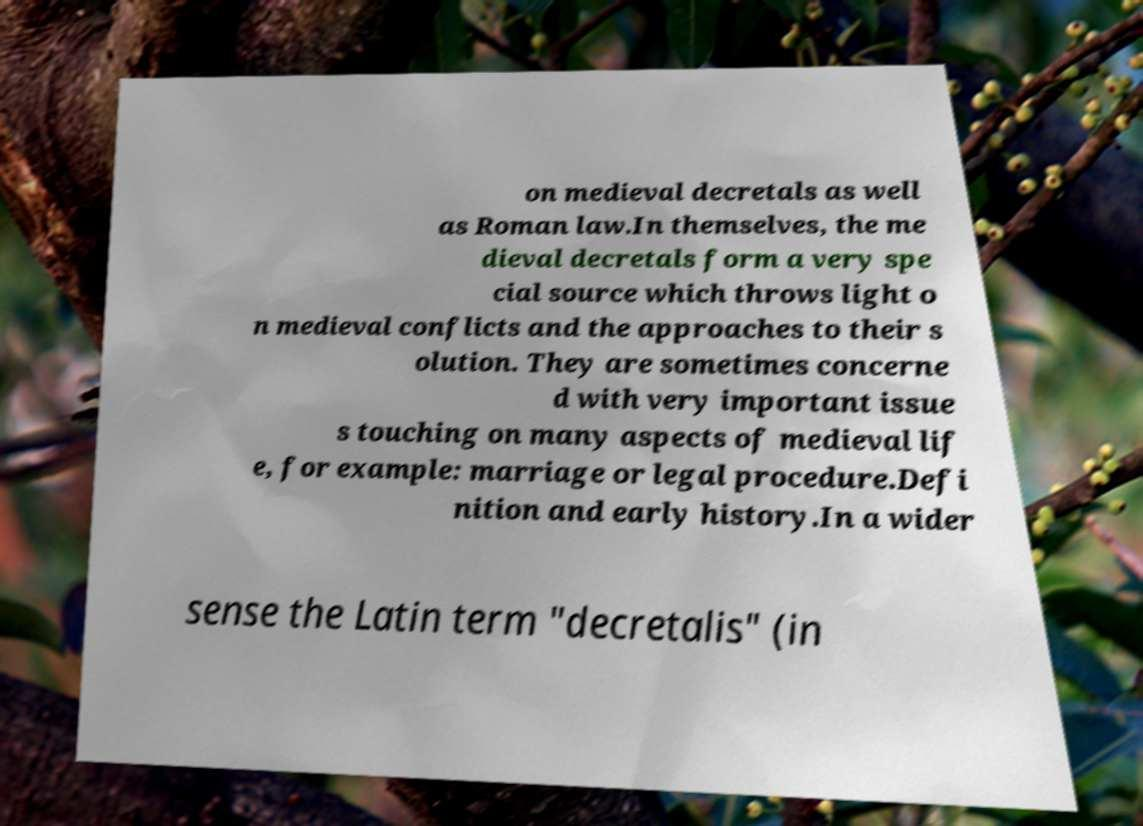Could you assist in decoding the text presented in this image and type it out clearly? on medieval decretals as well as Roman law.In themselves, the me dieval decretals form a very spe cial source which throws light o n medieval conflicts and the approaches to their s olution. They are sometimes concerne d with very important issue s touching on many aspects of medieval lif e, for example: marriage or legal procedure.Defi nition and early history.In a wider sense the Latin term "decretalis" (in 